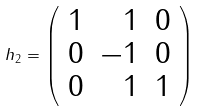Convert formula to latex. <formula><loc_0><loc_0><loc_500><loc_500>h _ { 2 } = \left ( \begin{array} { r r r } { 1 } & { 1 } & { 0 } \\ { 0 } & { - 1 } & { 0 } \\ { 0 } & { 1 } & { 1 } \end{array} \right )</formula> 